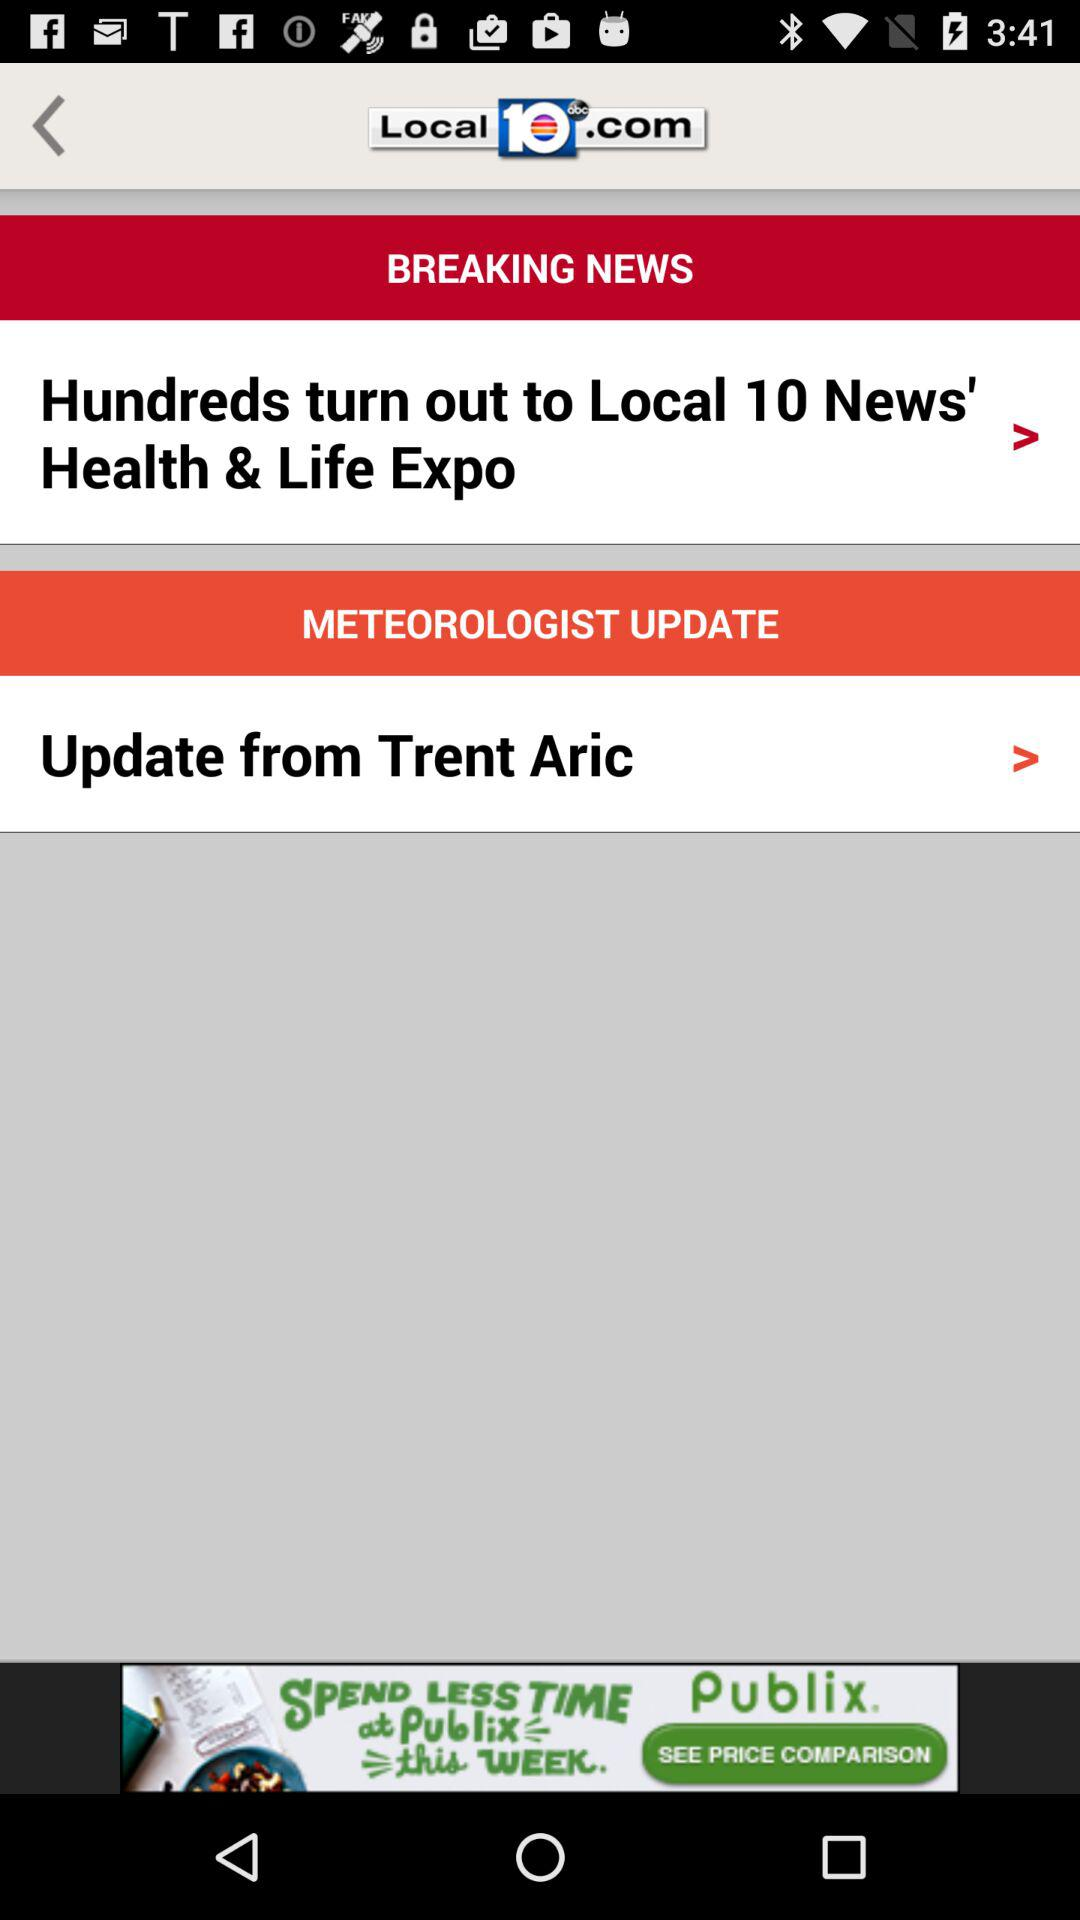How many arrows are pointing forward on this screen?
Answer the question using a single word or phrase. 2 